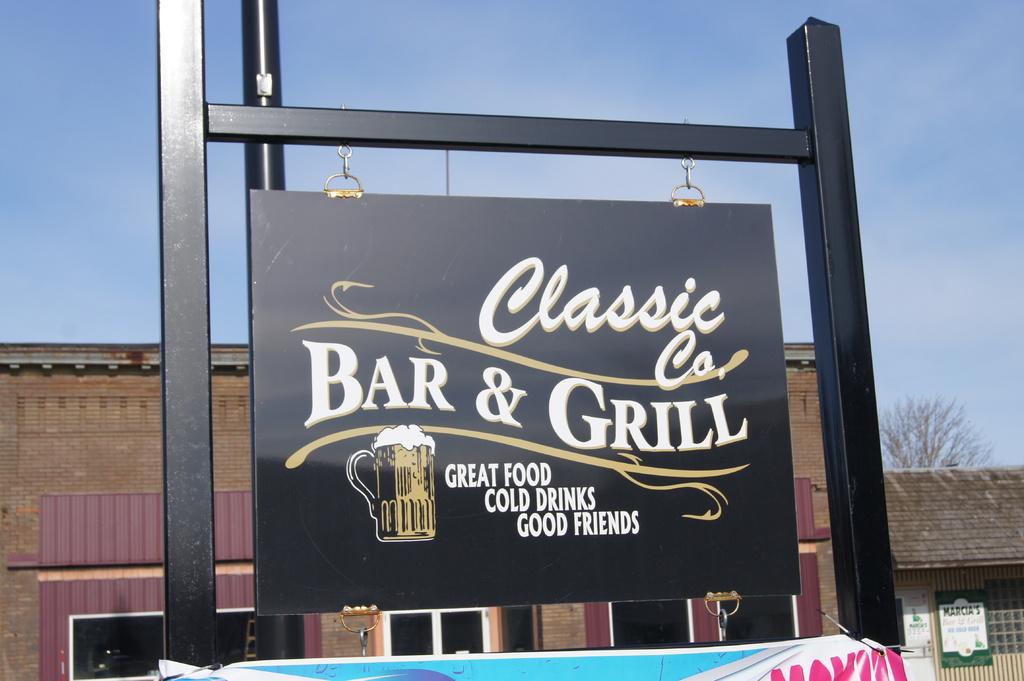Does the classic co bar and grill have great food?
Your answer should be very brief. Yes. What is the name of the bar?
Offer a terse response. Classic co. bar & grill. 